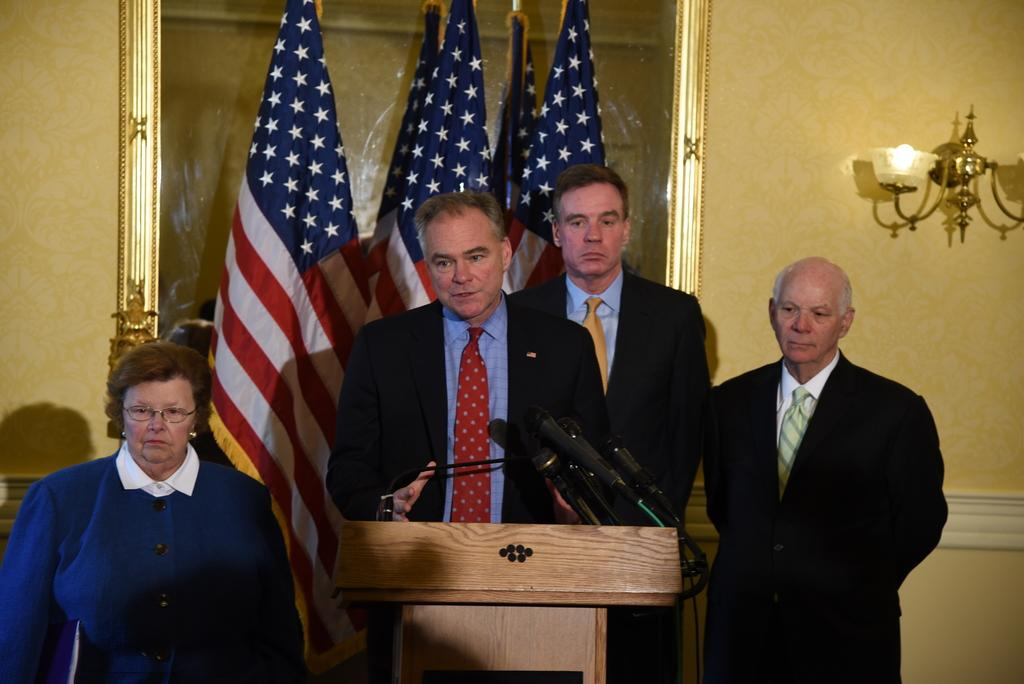Who is the main subject on the left side of the image? There is a lady standing on the left side of the image. How many men are present in the image? There are three men in the image. Where are the men positioned in relation to the lady? The men are standing in front of the lady. What is the purpose of the podium in the image? There is a podium in the image, which might be used for speeches or presentations. What is placed on the podium? There are microphones on the podium. What can be seen in the background of the image? There are flags, a photo frame, a light, and a wall in the background of the image. What type of wine is being served in the photo frame in the image? There is no wine present in the image, and the photo frame does not contain any wine. 